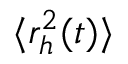Convert formula to latex. <formula><loc_0><loc_0><loc_500><loc_500>\langle r _ { h } ^ { 2 } ( t ) \rangle</formula> 